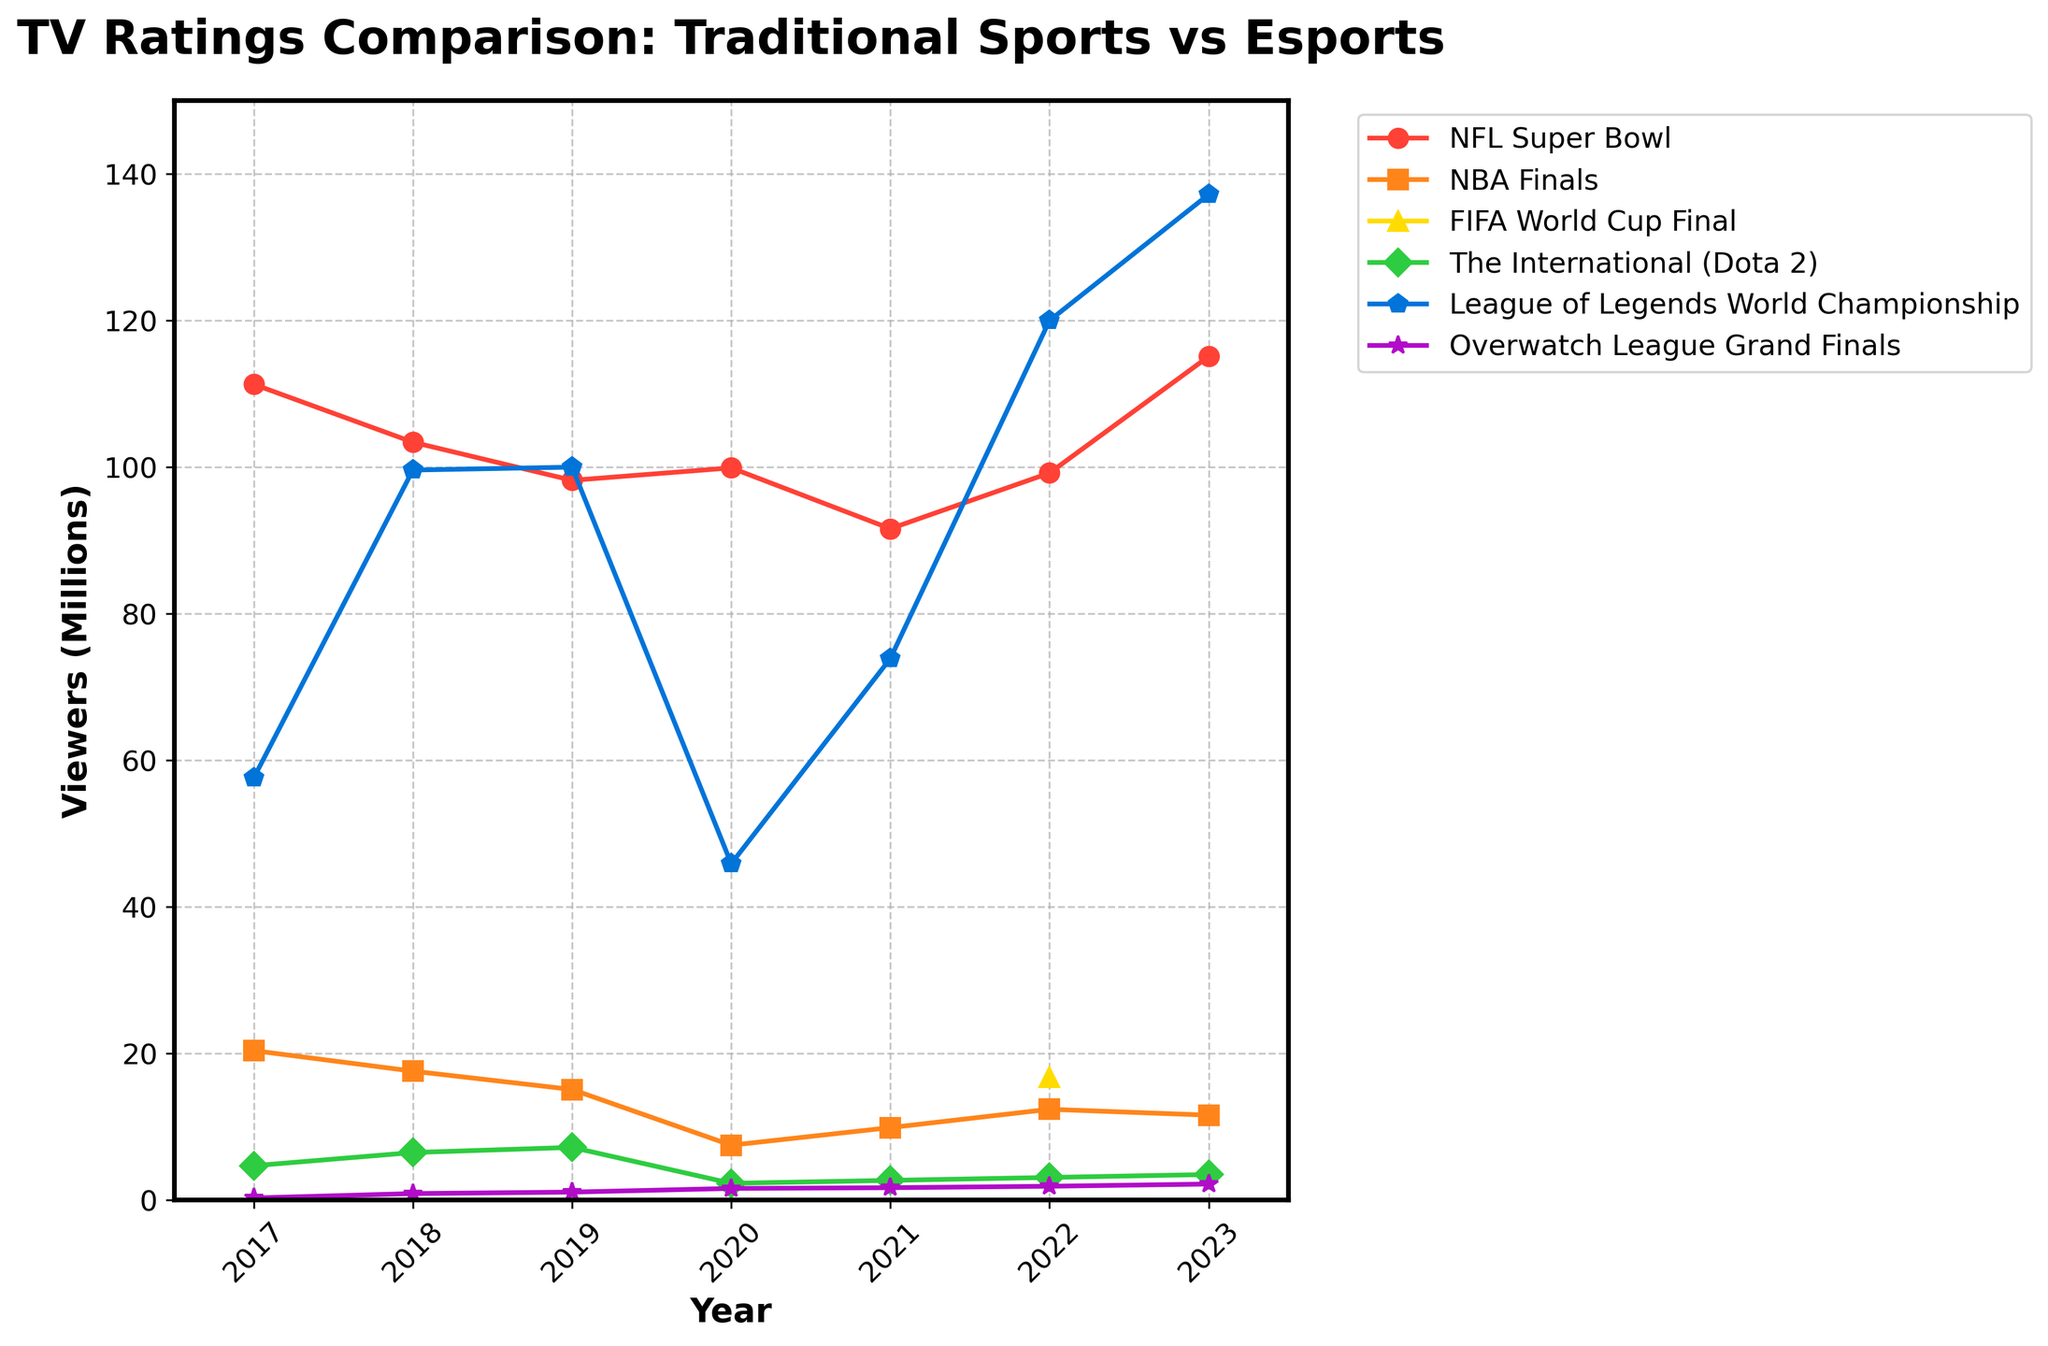Which year had the highest NFL Super Bowl ratings? First, identify the NFL Super Bowl line in the chart by its color. Then look at the peak point on the chart and note the year corresponding to that peak.
Answer: 2023 In which year did the League of Legends World Championship surpass the NFL Super Bowl in viewership? Find the two lines representing the League of Legends World Championship and the NFL Super Bowl. Look at the intersection point where the League of Legends World Championship line goes above the NFL Super Bowl line and note the corresponding year.
Answer: 2022 How did viewership for the NBA Finals change from 2017 to 2023? Locate the NBA Finals line and compare the y-values at 2017 and 2023. Calculate the difference between these values to find the change in viewership.
Answer: Decreased by 8.8 million What is the average viewership for The International (Dota 2) from 2017 to 2023? List the viewership values for The International (Dota 2) from each year provided. Sum these values and divide by the number of years to find the average.
Answer: 4.28 million Which esports event had the highest viewership in 2023? Locate the lines representing the different esports events for the year 2023. Identify the peak value among them.
Answer: League of Legends World Championship What is the combined viewership of the FIFA World Cup Final and The International (Dota 2) in 2022? Identify the values for both the FIFA World Cup Final and The International (Dota 2) in 2022. Add these values together to get the combined viewership.
Answer: 19.9 million Did the NBA Finals ratings ever fall below the ratings for any esports event from 2017 to 2023? Compare the lowest point of the NBA Finals line with each of the esports event lines within the given range of years.
Answer: Yes, in 2020 By how much did the Overwatch League Grand Finals viewership increase from 2017 to 2023? Compare the viewership values of the Overwatch League Grand Finals in 2017 and 2023 and calculate the difference.
Answer: 1.9 million In which years did the NFL Super Bowl ratings dip below 100 million viewers? Trace the NFL Super Bowl line to identify years where the ratings drop below the 100 million mark. Note the corresponding years.
Answer: 2018, 2019, 2021 What is the trend in League of Legends World Championship viewership from 2017 to 2023? Observe the League of Legends World Championship line from 2017 to 2023. Describe whether it is generally increasing, decreasing, or fluctuating.
Answer: Increasing 